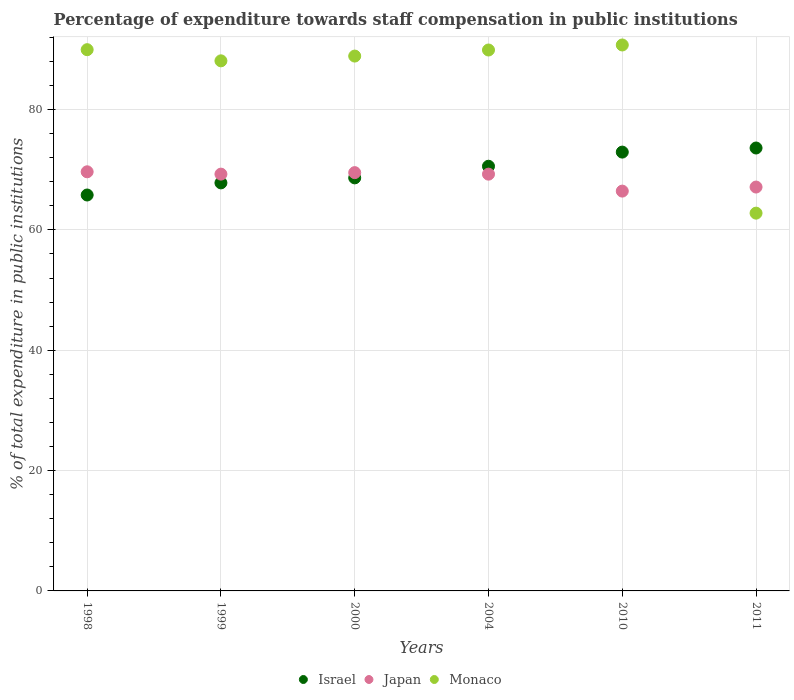How many different coloured dotlines are there?
Provide a short and direct response. 3. Is the number of dotlines equal to the number of legend labels?
Ensure brevity in your answer.  Yes. What is the percentage of expenditure towards staff compensation in Monaco in 2004?
Keep it short and to the point. 89.9. Across all years, what is the maximum percentage of expenditure towards staff compensation in Israel?
Your answer should be very brief. 73.61. Across all years, what is the minimum percentage of expenditure towards staff compensation in Monaco?
Keep it short and to the point. 62.78. In which year was the percentage of expenditure towards staff compensation in Japan minimum?
Ensure brevity in your answer.  2010. What is the total percentage of expenditure towards staff compensation in Japan in the graph?
Ensure brevity in your answer.  411.27. What is the difference between the percentage of expenditure towards staff compensation in Japan in 1999 and that in 2000?
Offer a terse response. -0.25. What is the difference between the percentage of expenditure towards staff compensation in Israel in 2004 and the percentage of expenditure towards staff compensation in Monaco in 2000?
Keep it short and to the point. -18.31. What is the average percentage of expenditure towards staff compensation in Israel per year?
Provide a succinct answer. 69.89. In the year 2004, what is the difference between the percentage of expenditure towards staff compensation in Monaco and percentage of expenditure towards staff compensation in Israel?
Provide a short and direct response. 19.32. In how many years, is the percentage of expenditure towards staff compensation in Monaco greater than 32 %?
Your response must be concise. 6. What is the ratio of the percentage of expenditure towards staff compensation in Monaco in 2000 to that in 2011?
Your answer should be very brief. 1.42. Is the difference between the percentage of expenditure towards staff compensation in Monaco in 1998 and 2010 greater than the difference between the percentage of expenditure towards staff compensation in Israel in 1998 and 2010?
Offer a very short reply. Yes. What is the difference between the highest and the second highest percentage of expenditure towards staff compensation in Japan?
Your response must be concise. 0.14. What is the difference between the highest and the lowest percentage of expenditure towards staff compensation in Japan?
Provide a short and direct response. 3.21. Is the percentage of expenditure towards staff compensation in Monaco strictly greater than the percentage of expenditure towards staff compensation in Japan over the years?
Keep it short and to the point. No. Is the percentage of expenditure towards staff compensation in Israel strictly less than the percentage of expenditure towards staff compensation in Japan over the years?
Your answer should be very brief. No. What is the difference between two consecutive major ticks on the Y-axis?
Your response must be concise. 20. Are the values on the major ticks of Y-axis written in scientific E-notation?
Offer a terse response. No. Does the graph contain any zero values?
Make the answer very short. No. Does the graph contain grids?
Provide a succinct answer. Yes. Where does the legend appear in the graph?
Make the answer very short. Bottom center. How many legend labels are there?
Ensure brevity in your answer.  3. How are the legend labels stacked?
Your answer should be very brief. Horizontal. What is the title of the graph?
Ensure brevity in your answer.  Percentage of expenditure towards staff compensation in public institutions. Does "World" appear as one of the legend labels in the graph?
Give a very brief answer. No. What is the label or title of the Y-axis?
Your answer should be very brief. % of total expenditure in public institutions. What is the % of total expenditure in public institutions in Israel in 1998?
Your response must be concise. 65.8. What is the % of total expenditure in public institutions in Japan in 1998?
Provide a succinct answer. 69.65. What is the % of total expenditure in public institutions in Monaco in 1998?
Keep it short and to the point. 89.95. What is the % of total expenditure in public institutions in Israel in 1999?
Provide a succinct answer. 67.81. What is the % of total expenditure in public institutions of Japan in 1999?
Your answer should be compact. 69.27. What is the % of total expenditure in public institutions of Monaco in 1999?
Your response must be concise. 88.09. What is the % of total expenditure in public institutions of Israel in 2000?
Offer a very short reply. 68.64. What is the % of total expenditure in public institutions in Japan in 2000?
Offer a terse response. 69.52. What is the % of total expenditure in public institutions of Monaco in 2000?
Give a very brief answer. 88.89. What is the % of total expenditure in public institutions of Israel in 2004?
Offer a terse response. 70.58. What is the % of total expenditure in public institutions of Japan in 2004?
Give a very brief answer. 69.26. What is the % of total expenditure in public institutions in Monaco in 2004?
Your answer should be compact. 89.9. What is the % of total expenditure in public institutions in Israel in 2010?
Your answer should be compact. 72.93. What is the % of total expenditure in public institutions of Japan in 2010?
Make the answer very short. 66.44. What is the % of total expenditure in public institutions of Monaco in 2010?
Make the answer very short. 90.73. What is the % of total expenditure in public institutions of Israel in 2011?
Ensure brevity in your answer.  73.61. What is the % of total expenditure in public institutions in Japan in 2011?
Provide a short and direct response. 67.12. What is the % of total expenditure in public institutions of Monaco in 2011?
Your response must be concise. 62.78. Across all years, what is the maximum % of total expenditure in public institutions in Israel?
Keep it short and to the point. 73.61. Across all years, what is the maximum % of total expenditure in public institutions of Japan?
Your answer should be very brief. 69.65. Across all years, what is the maximum % of total expenditure in public institutions of Monaco?
Provide a short and direct response. 90.73. Across all years, what is the minimum % of total expenditure in public institutions of Israel?
Offer a very short reply. 65.8. Across all years, what is the minimum % of total expenditure in public institutions in Japan?
Your answer should be very brief. 66.44. Across all years, what is the minimum % of total expenditure in public institutions in Monaco?
Provide a short and direct response. 62.78. What is the total % of total expenditure in public institutions of Israel in the graph?
Keep it short and to the point. 419.37. What is the total % of total expenditure in public institutions in Japan in the graph?
Keep it short and to the point. 411.27. What is the total % of total expenditure in public institutions of Monaco in the graph?
Your answer should be compact. 510.34. What is the difference between the % of total expenditure in public institutions in Israel in 1998 and that in 1999?
Your answer should be very brief. -2.01. What is the difference between the % of total expenditure in public institutions in Japan in 1998 and that in 1999?
Your answer should be compact. 0.39. What is the difference between the % of total expenditure in public institutions of Monaco in 1998 and that in 1999?
Your answer should be compact. 1.85. What is the difference between the % of total expenditure in public institutions in Israel in 1998 and that in 2000?
Offer a very short reply. -2.85. What is the difference between the % of total expenditure in public institutions of Japan in 1998 and that in 2000?
Offer a terse response. 0.14. What is the difference between the % of total expenditure in public institutions of Monaco in 1998 and that in 2000?
Your response must be concise. 1.06. What is the difference between the % of total expenditure in public institutions of Israel in 1998 and that in 2004?
Give a very brief answer. -4.78. What is the difference between the % of total expenditure in public institutions in Japan in 1998 and that in 2004?
Make the answer very short. 0.39. What is the difference between the % of total expenditure in public institutions of Monaco in 1998 and that in 2004?
Give a very brief answer. 0.05. What is the difference between the % of total expenditure in public institutions of Israel in 1998 and that in 2010?
Provide a succinct answer. -7.13. What is the difference between the % of total expenditure in public institutions of Japan in 1998 and that in 2010?
Offer a terse response. 3.21. What is the difference between the % of total expenditure in public institutions of Monaco in 1998 and that in 2010?
Give a very brief answer. -0.78. What is the difference between the % of total expenditure in public institutions in Israel in 1998 and that in 2011?
Ensure brevity in your answer.  -7.81. What is the difference between the % of total expenditure in public institutions of Japan in 1998 and that in 2011?
Your answer should be very brief. 2.54. What is the difference between the % of total expenditure in public institutions in Monaco in 1998 and that in 2011?
Your response must be concise. 27.17. What is the difference between the % of total expenditure in public institutions of Israel in 1999 and that in 2000?
Ensure brevity in your answer.  -0.83. What is the difference between the % of total expenditure in public institutions in Japan in 1999 and that in 2000?
Offer a terse response. -0.25. What is the difference between the % of total expenditure in public institutions of Monaco in 1999 and that in 2000?
Make the answer very short. -0.79. What is the difference between the % of total expenditure in public institutions in Israel in 1999 and that in 2004?
Ensure brevity in your answer.  -2.76. What is the difference between the % of total expenditure in public institutions in Japan in 1999 and that in 2004?
Make the answer very short. 0. What is the difference between the % of total expenditure in public institutions in Monaco in 1999 and that in 2004?
Your response must be concise. -1.8. What is the difference between the % of total expenditure in public institutions of Israel in 1999 and that in 2010?
Provide a succinct answer. -5.12. What is the difference between the % of total expenditure in public institutions of Japan in 1999 and that in 2010?
Your answer should be very brief. 2.82. What is the difference between the % of total expenditure in public institutions of Monaco in 1999 and that in 2010?
Provide a succinct answer. -2.64. What is the difference between the % of total expenditure in public institutions in Israel in 1999 and that in 2011?
Ensure brevity in your answer.  -5.8. What is the difference between the % of total expenditure in public institutions of Japan in 1999 and that in 2011?
Keep it short and to the point. 2.15. What is the difference between the % of total expenditure in public institutions of Monaco in 1999 and that in 2011?
Give a very brief answer. 25.31. What is the difference between the % of total expenditure in public institutions in Israel in 2000 and that in 2004?
Make the answer very short. -1.93. What is the difference between the % of total expenditure in public institutions in Japan in 2000 and that in 2004?
Give a very brief answer. 0.25. What is the difference between the % of total expenditure in public institutions in Monaco in 2000 and that in 2004?
Give a very brief answer. -1.01. What is the difference between the % of total expenditure in public institutions of Israel in 2000 and that in 2010?
Provide a short and direct response. -4.28. What is the difference between the % of total expenditure in public institutions in Japan in 2000 and that in 2010?
Keep it short and to the point. 3.07. What is the difference between the % of total expenditure in public institutions of Monaco in 2000 and that in 2010?
Offer a very short reply. -1.84. What is the difference between the % of total expenditure in public institutions of Israel in 2000 and that in 2011?
Give a very brief answer. -4.96. What is the difference between the % of total expenditure in public institutions of Japan in 2000 and that in 2011?
Keep it short and to the point. 2.4. What is the difference between the % of total expenditure in public institutions in Monaco in 2000 and that in 2011?
Give a very brief answer. 26.1. What is the difference between the % of total expenditure in public institutions of Israel in 2004 and that in 2010?
Offer a terse response. -2.35. What is the difference between the % of total expenditure in public institutions in Japan in 2004 and that in 2010?
Make the answer very short. 2.82. What is the difference between the % of total expenditure in public institutions in Monaco in 2004 and that in 2010?
Offer a terse response. -0.83. What is the difference between the % of total expenditure in public institutions in Israel in 2004 and that in 2011?
Offer a terse response. -3.03. What is the difference between the % of total expenditure in public institutions in Japan in 2004 and that in 2011?
Your response must be concise. 2.14. What is the difference between the % of total expenditure in public institutions in Monaco in 2004 and that in 2011?
Keep it short and to the point. 27.11. What is the difference between the % of total expenditure in public institutions in Israel in 2010 and that in 2011?
Provide a succinct answer. -0.68. What is the difference between the % of total expenditure in public institutions in Japan in 2010 and that in 2011?
Your answer should be very brief. -0.67. What is the difference between the % of total expenditure in public institutions in Monaco in 2010 and that in 2011?
Ensure brevity in your answer.  27.95. What is the difference between the % of total expenditure in public institutions of Israel in 1998 and the % of total expenditure in public institutions of Japan in 1999?
Offer a very short reply. -3.47. What is the difference between the % of total expenditure in public institutions in Israel in 1998 and the % of total expenditure in public institutions in Monaco in 1999?
Your answer should be compact. -22.3. What is the difference between the % of total expenditure in public institutions of Japan in 1998 and the % of total expenditure in public institutions of Monaco in 1999?
Your response must be concise. -18.44. What is the difference between the % of total expenditure in public institutions of Israel in 1998 and the % of total expenditure in public institutions of Japan in 2000?
Your response must be concise. -3.72. What is the difference between the % of total expenditure in public institutions of Israel in 1998 and the % of total expenditure in public institutions of Monaco in 2000?
Ensure brevity in your answer.  -23.09. What is the difference between the % of total expenditure in public institutions of Japan in 1998 and the % of total expenditure in public institutions of Monaco in 2000?
Your response must be concise. -19.23. What is the difference between the % of total expenditure in public institutions of Israel in 1998 and the % of total expenditure in public institutions of Japan in 2004?
Make the answer very short. -3.47. What is the difference between the % of total expenditure in public institutions in Israel in 1998 and the % of total expenditure in public institutions in Monaco in 2004?
Offer a very short reply. -24.1. What is the difference between the % of total expenditure in public institutions of Japan in 1998 and the % of total expenditure in public institutions of Monaco in 2004?
Your answer should be very brief. -20.24. What is the difference between the % of total expenditure in public institutions in Israel in 1998 and the % of total expenditure in public institutions in Japan in 2010?
Provide a short and direct response. -0.65. What is the difference between the % of total expenditure in public institutions of Israel in 1998 and the % of total expenditure in public institutions of Monaco in 2010?
Give a very brief answer. -24.93. What is the difference between the % of total expenditure in public institutions of Japan in 1998 and the % of total expenditure in public institutions of Monaco in 2010?
Ensure brevity in your answer.  -21.07. What is the difference between the % of total expenditure in public institutions in Israel in 1998 and the % of total expenditure in public institutions in Japan in 2011?
Your response must be concise. -1.32. What is the difference between the % of total expenditure in public institutions of Israel in 1998 and the % of total expenditure in public institutions of Monaco in 2011?
Offer a terse response. 3.02. What is the difference between the % of total expenditure in public institutions in Japan in 1998 and the % of total expenditure in public institutions in Monaco in 2011?
Keep it short and to the point. 6.87. What is the difference between the % of total expenditure in public institutions of Israel in 1999 and the % of total expenditure in public institutions of Japan in 2000?
Make the answer very short. -1.7. What is the difference between the % of total expenditure in public institutions in Israel in 1999 and the % of total expenditure in public institutions in Monaco in 2000?
Provide a succinct answer. -21.07. What is the difference between the % of total expenditure in public institutions of Japan in 1999 and the % of total expenditure in public institutions of Monaco in 2000?
Keep it short and to the point. -19.62. What is the difference between the % of total expenditure in public institutions in Israel in 1999 and the % of total expenditure in public institutions in Japan in 2004?
Your answer should be very brief. -1.45. What is the difference between the % of total expenditure in public institutions of Israel in 1999 and the % of total expenditure in public institutions of Monaco in 2004?
Provide a short and direct response. -22.08. What is the difference between the % of total expenditure in public institutions in Japan in 1999 and the % of total expenditure in public institutions in Monaco in 2004?
Ensure brevity in your answer.  -20.63. What is the difference between the % of total expenditure in public institutions of Israel in 1999 and the % of total expenditure in public institutions of Japan in 2010?
Provide a short and direct response. 1.37. What is the difference between the % of total expenditure in public institutions in Israel in 1999 and the % of total expenditure in public institutions in Monaco in 2010?
Offer a very short reply. -22.92. What is the difference between the % of total expenditure in public institutions of Japan in 1999 and the % of total expenditure in public institutions of Monaco in 2010?
Provide a succinct answer. -21.46. What is the difference between the % of total expenditure in public institutions of Israel in 1999 and the % of total expenditure in public institutions of Japan in 2011?
Offer a terse response. 0.69. What is the difference between the % of total expenditure in public institutions of Israel in 1999 and the % of total expenditure in public institutions of Monaco in 2011?
Your response must be concise. 5.03. What is the difference between the % of total expenditure in public institutions in Japan in 1999 and the % of total expenditure in public institutions in Monaco in 2011?
Give a very brief answer. 6.48. What is the difference between the % of total expenditure in public institutions of Israel in 2000 and the % of total expenditure in public institutions of Japan in 2004?
Offer a terse response. -0.62. What is the difference between the % of total expenditure in public institutions of Israel in 2000 and the % of total expenditure in public institutions of Monaco in 2004?
Make the answer very short. -21.25. What is the difference between the % of total expenditure in public institutions of Japan in 2000 and the % of total expenditure in public institutions of Monaco in 2004?
Provide a short and direct response. -20.38. What is the difference between the % of total expenditure in public institutions of Israel in 2000 and the % of total expenditure in public institutions of Japan in 2010?
Your answer should be compact. 2.2. What is the difference between the % of total expenditure in public institutions in Israel in 2000 and the % of total expenditure in public institutions in Monaco in 2010?
Ensure brevity in your answer.  -22.09. What is the difference between the % of total expenditure in public institutions of Japan in 2000 and the % of total expenditure in public institutions of Monaco in 2010?
Keep it short and to the point. -21.21. What is the difference between the % of total expenditure in public institutions in Israel in 2000 and the % of total expenditure in public institutions in Japan in 2011?
Your answer should be very brief. 1.52. What is the difference between the % of total expenditure in public institutions of Israel in 2000 and the % of total expenditure in public institutions of Monaco in 2011?
Ensure brevity in your answer.  5.86. What is the difference between the % of total expenditure in public institutions of Japan in 2000 and the % of total expenditure in public institutions of Monaco in 2011?
Provide a succinct answer. 6.73. What is the difference between the % of total expenditure in public institutions of Israel in 2004 and the % of total expenditure in public institutions of Japan in 2010?
Provide a short and direct response. 4.13. What is the difference between the % of total expenditure in public institutions in Israel in 2004 and the % of total expenditure in public institutions in Monaco in 2010?
Offer a very short reply. -20.15. What is the difference between the % of total expenditure in public institutions in Japan in 2004 and the % of total expenditure in public institutions in Monaco in 2010?
Your response must be concise. -21.47. What is the difference between the % of total expenditure in public institutions in Israel in 2004 and the % of total expenditure in public institutions in Japan in 2011?
Your answer should be very brief. 3.46. What is the difference between the % of total expenditure in public institutions in Israel in 2004 and the % of total expenditure in public institutions in Monaco in 2011?
Your response must be concise. 7.79. What is the difference between the % of total expenditure in public institutions of Japan in 2004 and the % of total expenditure in public institutions of Monaco in 2011?
Give a very brief answer. 6.48. What is the difference between the % of total expenditure in public institutions of Israel in 2010 and the % of total expenditure in public institutions of Japan in 2011?
Make the answer very short. 5.81. What is the difference between the % of total expenditure in public institutions in Israel in 2010 and the % of total expenditure in public institutions in Monaco in 2011?
Provide a succinct answer. 10.15. What is the difference between the % of total expenditure in public institutions in Japan in 2010 and the % of total expenditure in public institutions in Monaco in 2011?
Ensure brevity in your answer.  3.66. What is the average % of total expenditure in public institutions of Israel per year?
Offer a very short reply. 69.89. What is the average % of total expenditure in public institutions of Japan per year?
Ensure brevity in your answer.  68.54. What is the average % of total expenditure in public institutions of Monaco per year?
Provide a succinct answer. 85.06. In the year 1998, what is the difference between the % of total expenditure in public institutions of Israel and % of total expenditure in public institutions of Japan?
Your answer should be compact. -3.86. In the year 1998, what is the difference between the % of total expenditure in public institutions of Israel and % of total expenditure in public institutions of Monaco?
Provide a succinct answer. -24.15. In the year 1998, what is the difference between the % of total expenditure in public institutions of Japan and % of total expenditure in public institutions of Monaco?
Provide a succinct answer. -20.29. In the year 1999, what is the difference between the % of total expenditure in public institutions in Israel and % of total expenditure in public institutions in Japan?
Offer a very short reply. -1.45. In the year 1999, what is the difference between the % of total expenditure in public institutions in Israel and % of total expenditure in public institutions in Monaco?
Your answer should be very brief. -20.28. In the year 1999, what is the difference between the % of total expenditure in public institutions of Japan and % of total expenditure in public institutions of Monaco?
Make the answer very short. -18.83. In the year 2000, what is the difference between the % of total expenditure in public institutions of Israel and % of total expenditure in public institutions of Japan?
Offer a very short reply. -0.87. In the year 2000, what is the difference between the % of total expenditure in public institutions of Israel and % of total expenditure in public institutions of Monaco?
Ensure brevity in your answer.  -20.24. In the year 2000, what is the difference between the % of total expenditure in public institutions in Japan and % of total expenditure in public institutions in Monaco?
Provide a short and direct response. -19.37. In the year 2004, what is the difference between the % of total expenditure in public institutions in Israel and % of total expenditure in public institutions in Japan?
Offer a terse response. 1.31. In the year 2004, what is the difference between the % of total expenditure in public institutions in Israel and % of total expenditure in public institutions in Monaco?
Your answer should be very brief. -19.32. In the year 2004, what is the difference between the % of total expenditure in public institutions in Japan and % of total expenditure in public institutions in Monaco?
Provide a succinct answer. -20.63. In the year 2010, what is the difference between the % of total expenditure in public institutions of Israel and % of total expenditure in public institutions of Japan?
Give a very brief answer. 6.48. In the year 2010, what is the difference between the % of total expenditure in public institutions in Israel and % of total expenditure in public institutions in Monaco?
Your answer should be compact. -17.8. In the year 2010, what is the difference between the % of total expenditure in public institutions of Japan and % of total expenditure in public institutions of Monaco?
Give a very brief answer. -24.28. In the year 2011, what is the difference between the % of total expenditure in public institutions in Israel and % of total expenditure in public institutions in Japan?
Offer a terse response. 6.49. In the year 2011, what is the difference between the % of total expenditure in public institutions of Israel and % of total expenditure in public institutions of Monaco?
Provide a short and direct response. 10.83. In the year 2011, what is the difference between the % of total expenditure in public institutions in Japan and % of total expenditure in public institutions in Monaco?
Keep it short and to the point. 4.34. What is the ratio of the % of total expenditure in public institutions in Israel in 1998 to that in 1999?
Make the answer very short. 0.97. What is the ratio of the % of total expenditure in public institutions of Japan in 1998 to that in 1999?
Provide a succinct answer. 1.01. What is the ratio of the % of total expenditure in public institutions in Israel in 1998 to that in 2000?
Offer a terse response. 0.96. What is the ratio of the % of total expenditure in public institutions in Japan in 1998 to that in 2000?
Ensure brevity in your answer.  1. What is the ratio of the % of total expenditure in public institutions of Monaco in 1998 to that in 2000?
Offer a very short reply. 1.01. What is the ratio of the % of total expenditure in public institutions of Israel in 1998 to that in 2004?
Provide a short and direct response. 0.93. What is the ratio of the % of total expenditure in public institutions of Israel in 1998 to that in 2010?
Offer a very short reply. 0.9. What is the ratio of the % of total expenditure in public institutions of Japan in 1998 to that in 2010?
Your response must be concise. 1.05. What is the ratio of the % of total expenditure in public institutions of Israel in 1998 to that in 2011?
Offer a terse response. 0.89. What is the ratio of the % of total expenditure in public institutions in Japan in 1998 to that in 2011?
Ensure brevity in your answer.  1.04. What is the ratio of the % of total expenditure in public institutions in Monaco in 1998 to that in 2011?
Keep it short and to the point. 1.43. What is the ratio of the % of total expenditure in public institutions in Israel in 1999 to that in 2000?
Ensure brevity in your answer.  0.99. What is the ratio of the % of total expenditure in public institutions of Japan in 1999 to that in 2000?
Your answer should be compact. 1. What is the ratio of the % of total expenditure in public institutions of Monaco in 1999 to that in 2000?
Provide a short and direct response. 0.99. What is the ratio of the % of total expenditure in public institutions of Israel in 1999 to that in 2004?
Offer a very short reply. 0.96. What is the ratio of the % of total expenditure in public institutions in Japan in 1999 to that in 2004?
Offer a very short reply. 1. What is the ratio of the % of total expenditure in public institutions in Monaco in 1999 to that in 2004?
Ensure brevity in your answer.  0.98. What is the ratio of the % of total expenditure in public institutions of Israel in 1999 to that in 2010?
Your response must be concise. 0.93. What is the ratio of the % of total expenditure in public institutions of Japan in 1999 to that in 2010?
Provide a short and direct response. 1.04. What is the ratio of the % of total expenditure in public institutions in Israel in 1999 to that in 2011?
Give a very brief answer. 0.92. What is the ratio of the % of total expenditure in public institutions of Japan in 1999 to that in 2011?
Provide a short and direct response. 1.03. What is the ratio of the % of total expenditure in public institutions in Monaco in 1999 to that in 2011?
Provide a succinct answer. 1.4. What is the ratio of the % of total expenditure in public institutions in Israel in 2000 to that in 2004?
Your response must be concise. 0.97. What is the ratio of the % of total expenditure in public institutions in Japan in 2000 to that in 2004?
Make the answer very short. 1. What is the ratio of the % of total expenditure in public institutions in Israel in 2000 to that in 2010?
Your response must be concise. 0.94. What is the ratio of the % of total expenditure in public institutions of Japan in 2000 to that in 2010?
Your answer should be compact. 1.05. What is the ratio of the % of total expenditure in public institutions of Monaco in 2000 to that in 2010?
Provide a short and direct response. 0.98. What is the ratio of the % of total expenditure in public institutions of Israel in 2000 to that in 2011?
Offer a very short reply. 0.93. What is the ratio of the % of total expenditure in public institutions of Japan in 2000 to that in 2011?
Give a very brief answer. 1.04. What is the ratio of the % of total expenditure in public institutions of Monaco in 2000 to that in 2011?
Your answer should be very brief. 1.42. What is the ratio of the % of total expenditure in public institutions of Israel in 2004 to that in 2010?
Offer a very short reply. 0.97. What is the ratio of the % of total expenditure in public institutions of Japan in 2004 to that in 2010?
Provide a succinct answer. 1.04. What is the ratio of the % of total expenditure in public institutions in Israel in 2004 to that in 2011?
Keep it short and to the point. 0.96. What is the ratio of the % of total expenditure in public institutions of Japan in 2004 to that in 2011?
Make the answer very short. 1.03. What is the ratio of the % of total expenditure in public institutions in Monaco in 2004 to that in 2011?
Offer a terse response. 1.43. What is the ratio of the % of total expenditure in public institutions of Israel in 2010 to that in 2011?
Keep it short and to the point. 0.99. What is the ratio of the % of total expenditure in public institutions in Japan in 2010 to that in 2011?
Provide a succinct answer. 0.99. What is the ratio of the % of total expenditure in public institutions in Monaco in 2010 to that in 2011?
Your answer should be compact. 1.45. What is the difference between the highest and the second highest % of total expenditure in public institutions in Israel?
Ensure brevity in your answer.  0.68. What is the difference between the highest and the second highest % of total expenditure in public institutions of Japan?
Ensure brevity in your answer.  0.14. What is the difference between the highest and the second highest % of total expenditure in public institutions of Monaco?
Your answer should be very brief. 0.78. What is the difference between the highest and the lowest % of total expenditure in public institutions of Israel?
Offer a very short reply. 7.81. What is the difference between the highest and the lowest % of total expenditure in public institutions in Japan?
Give a very brief answer. 3.21. What is the difference between the highest and the lowest % of total expenditure in public institutions in Monaco?
Your answer should be very brief. 27.95. 